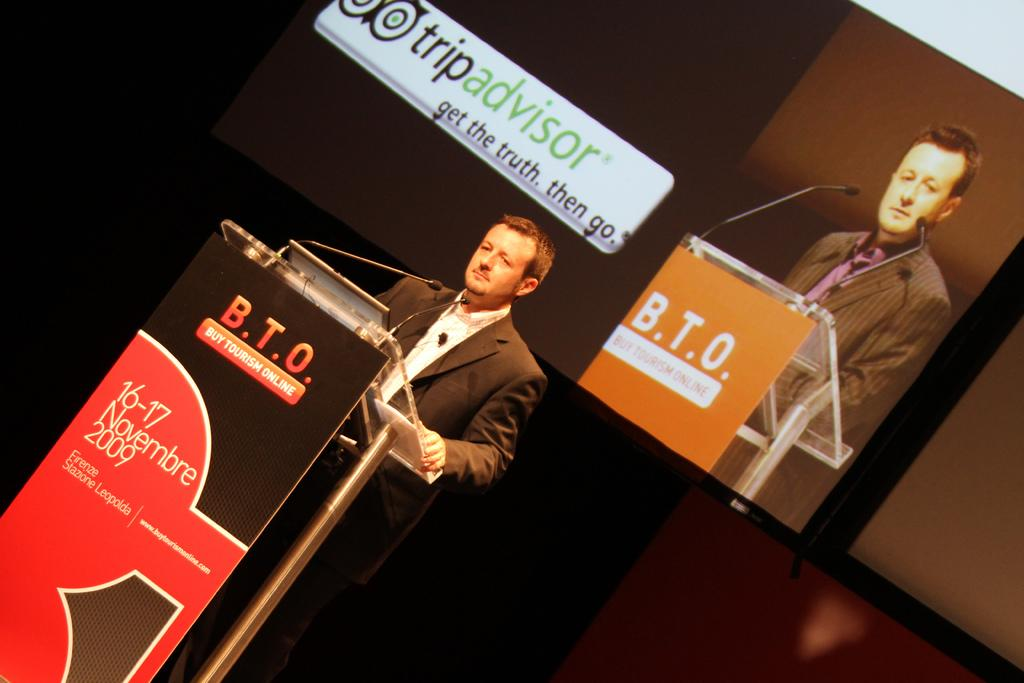Who is the main subject in the image? There is a man in the image. What is the man doing in the image? The man is standing in front of a podium. What objects are present that might be used for amplifying sound? There are microphones in the image. What can be seen in the background of the image? There is a projector screen in the background of the image. What type of thumb is being used to make a selection in the image? There is no thumb or selection process present in the image. 